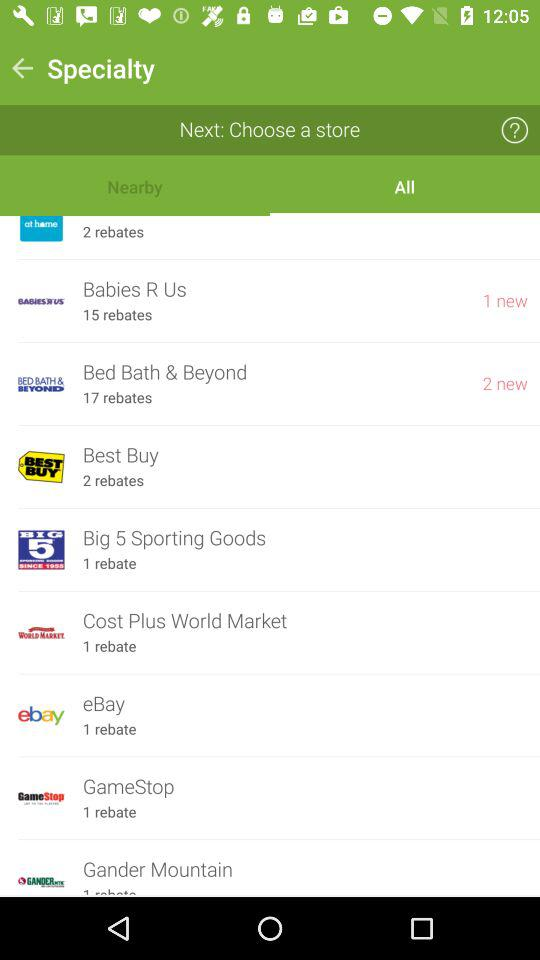Which store has the most rebates?
Answer the question using a single word or phrase. Bed Bath & Beyond 